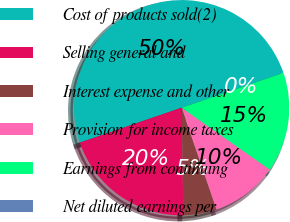Convert chart to OTSL. <chart><loc_0><loc_0><loc_500><loc_500><pie_chart><fcel>Cost of products sold(2)<fcel>Selling general and<fcel>Interest expense and other<fcel>Provision for income taxes<fcel>Earnings from continuing<fcel>Net diluted earnings per<nl><fcel>50.0%<fcel>20.0%<fcel>5.0%<fcel>10.0%<fcel>15.0%<fcel>0.0%<nl></chart> 